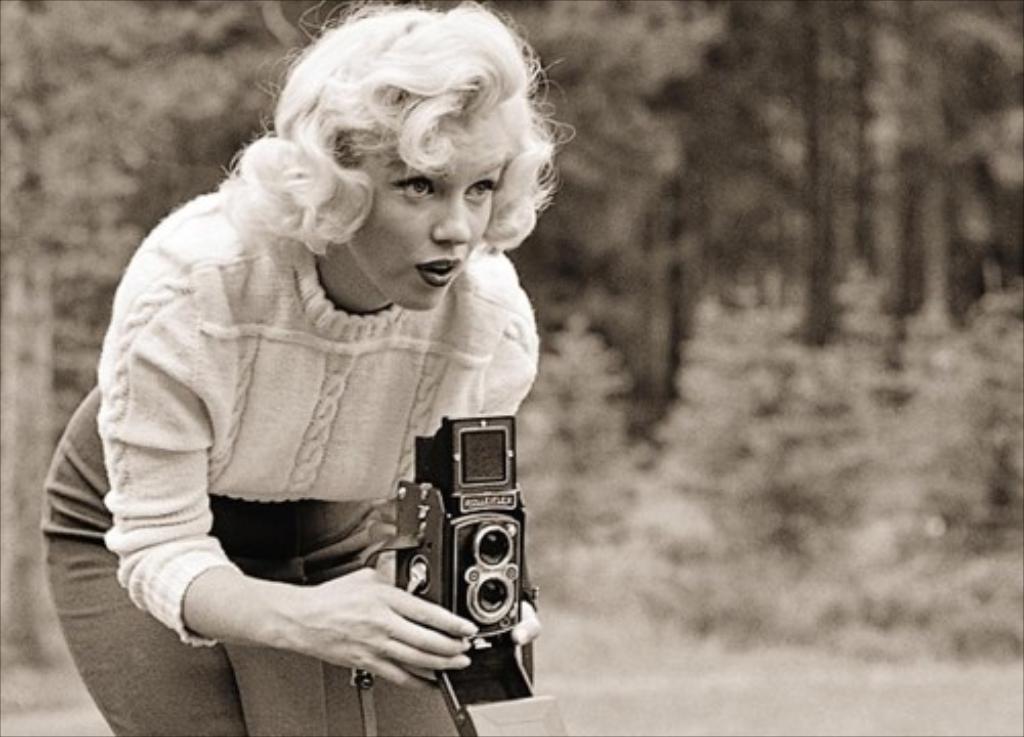Could you give a brief overview of what you see in this image? This is the picture of a woman standing and taking the picture with the camera and in back ground there are trees. 